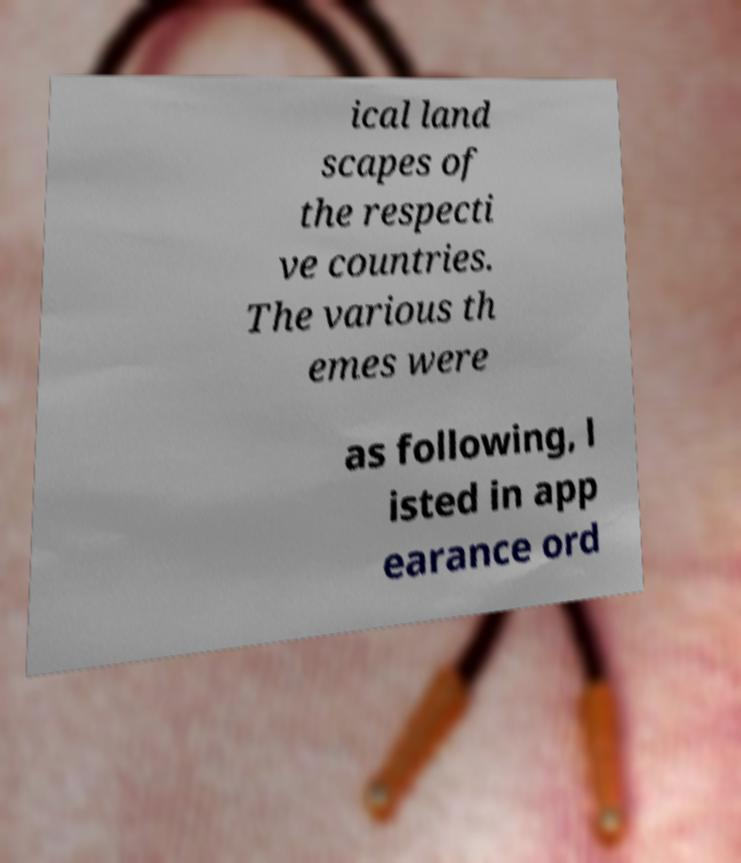Please read and relay the text visible in this image. What does it say? ical land scapes of the respecti ve countries. The various th emes were as following, l isted in app earance ord 